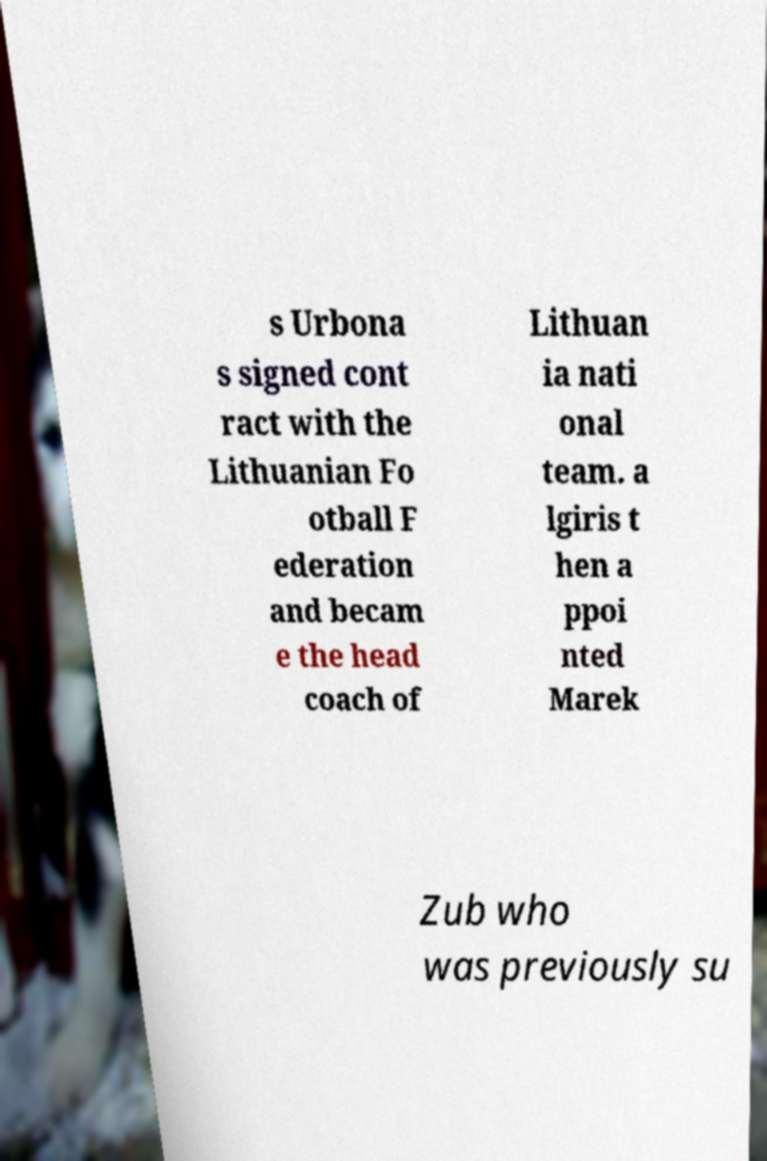Can you read and provide the text displayed in the image?This photo seems to have some interesting text. Can you extract and type it out for me? s Urbona s signed cont ract with the Lithuanian Fo otball F ederation and becam e the head coach of Lithuan ia nati onal team. a lgiris t hen a ppoi nted Marek Zub who was previously su 